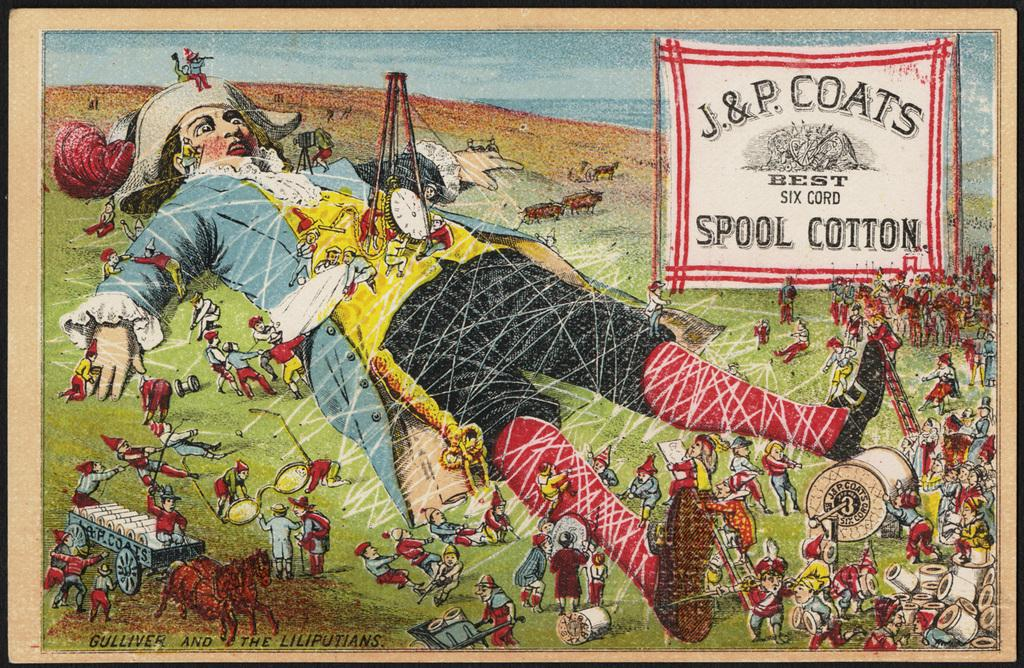Provide a one-sentence caption for the provided image. J. & P. Coats have created an advertisement for their spool cotton. 